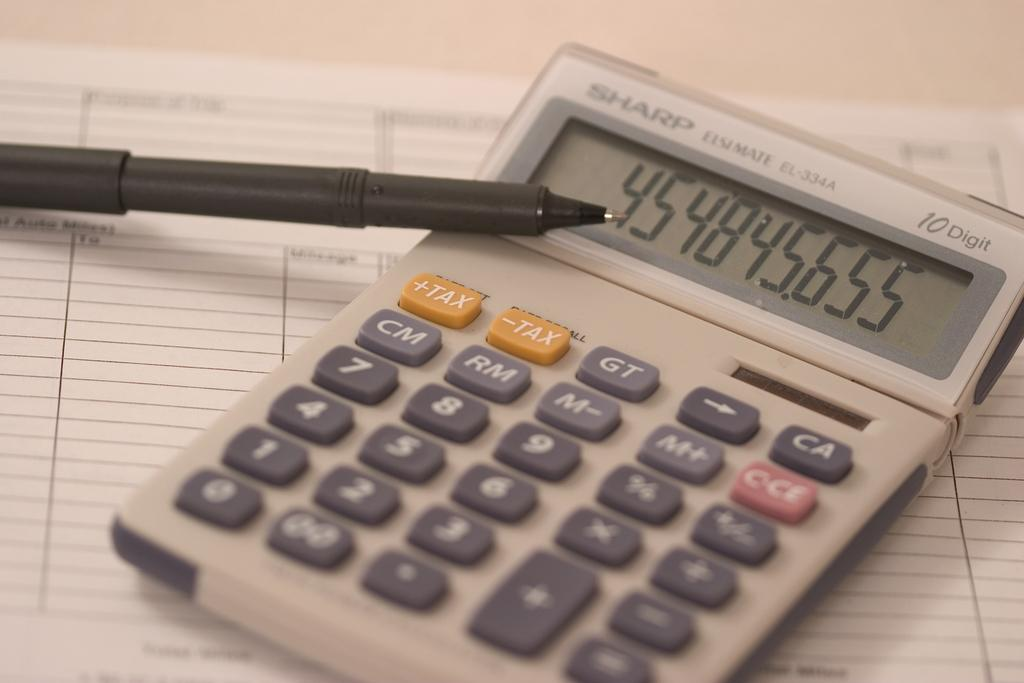<image>
Share a concise interpretation of the image provided. the numbers 4548 are on the front of the calculator 